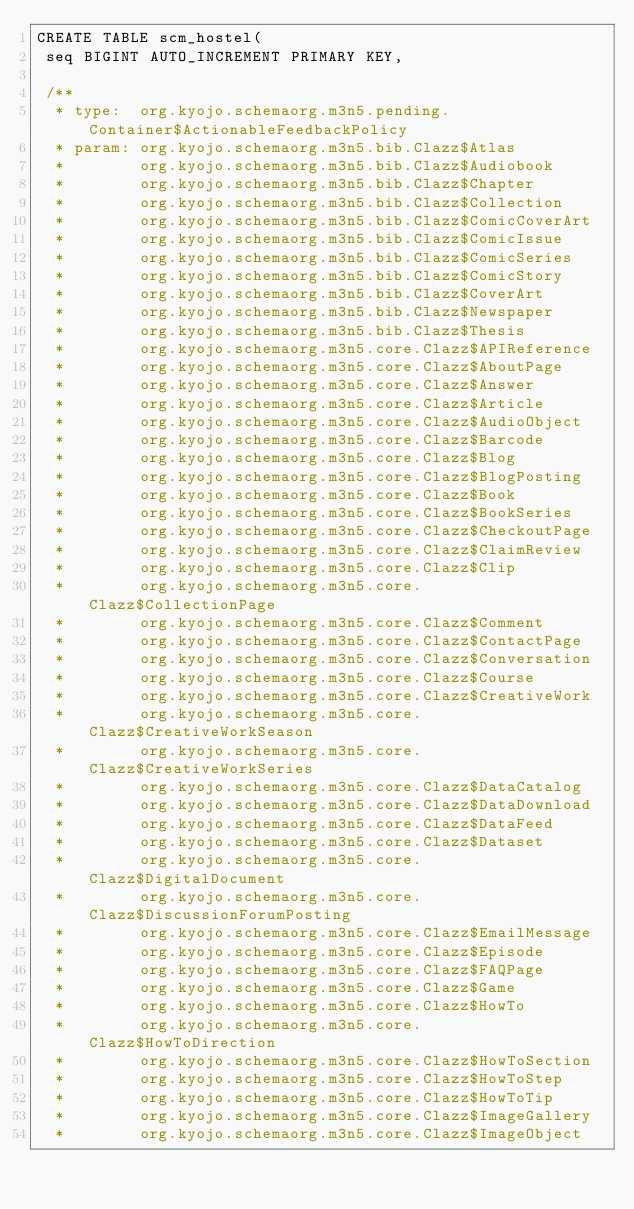<code> <loc_0><loc_0><loc_500><loc_500><_SQL_>CREATE TABLE scm_hostel(
 seq BIGINT AUTO_INCREMENT PRIMARY KEY,

 /**
  * type:  org.kyojo.schemaorg.m3n5.pending.Container$ActionableFeedbackPolicy
  * param: org.kyojo.schemaorg.m3n5.bib.Clazz$Atlas
  *        org.kyojo.schemaorg.m3n5.bib.Clazz$Audiobook
  *        org.kyojo.schemaorg.m3n5.bib.Clazz$Chapter
  *        org.kyojo.schemaorg.m3n5.bib.Clazz$Collection
  *        org.kyojo.schemaorg.m3n5.bib.Clazz$ComicCoverArt
  *        org.kyojo.schemaorg.m3n5.bib.Clazz$ComicIssue
  *        org.kyojo.schemaorg.m3n5.bib.Clazz$ComicSeries
  *        org.kyojo.schemaorg.m3n5.bib.Clazz$ComicStory
  *        org.kyojo.schemaorg.m3n5.bib.Clazz$CoverArt
  *        org.kyojo.schemaorg.m3n5.bib.Clazz$Newspaper
  *        org.kyojo.schemaorg.m3n5.bib.Clazz$Thesis
  *        org.kyojo.schemaorg.m3n5.core.Clazz$APIReference
  *        org.kyojo.schemaorg.m3n5.core.Clazz$AboutPage
  *        org.kyojo.schemaorg.m3n5.core.Clazz$Answer
  *        org.kyojo.schemaorg.m3n5.core.Clazz$Article
  *        org.kyojo.schemaorg.m3n5.core.Clazz$AudioObject
  *        org.kyojo.schemaorg.m3n5.core.Clazz$Barcode
  *        org.kyojo.schemaorg.m3n5.core.Clazz$Blog
  *        org.kyojo.schemaorg.m3n5.core.Clazz$BlogPosting
  *        org.kyojo.schemaorg.m3n5.core.Clazz$Book
  *        org.kyojo.schemaorg.m3n5.core.Clazz$BookSeries
  *        org.kyojo.schemaorg.m3n5.core.Clazz$CheckoutPage
  *        org.kyojo.schemaorg.m3n5.core.Clazz$ClaimReview
  *        org.kyojo.schemaorg.m3n5.core.Clazz$Clip
  *        org.kyojo.schemaorg.m3n5.core.Clazz$CollectionPage
  *        org.kyojo.schemaorg.m3n5.core.Clazz$Comment
  *        org.kyojo.schemaorg.m3n5.core.Clazz$ContactPage
  *        org.kyojo.schemaorg.m3n5.core.Clazz$Conversation
  *        org.kyojo.schemaorg.m3n5.core.Clazz$Course
  *        org.kyojo.schemaorg.m3n5.core.Clazz$CreativeWork
  *        org.kyojo.schemaorg.m3n5.core.Clazz$CreativeWorkSeason
  *        org.kyojo.schemaorg.m3n5.core.Clazz$CreativeWorkSeries
  *        org.kyojo.schemaorg.m3n5.core.Clazz$DataCatalog
  *        org.kyojo.schemaorg.m3n5.core.Clazz$DataDownload
  *        org.kyojo.schemaorg.m3n5.core.Clazz$DataFeed
  *        org.kyojo.schemaorg.m3n5.core.Clazz$Dataset
  *        org.kyojo.schemaorg.m3n5.core.Clazz$DigitalDocument
  *        org.kyojo.schemaorg.m3n5.core.Clazz$DiscussionForumPosting
  *        org.kyojo.schemaorg.m3n5.core.Clazz$EmailMessage
  *        org.kyojo.schemaorg.m3n5.core.Clazz$Episode
  *        org.kyojo.schemaorg.m3n5.core.Clazz$FAQPage
  *        org.kyojo.schemaorg.m3n5.core.Clazz$Game
  *        org.kyojo.schemaorg.m3n5.core.Clazz$HowTo
  *        org.kyojo.schemaorg.m3n5.core.Clazz$HowToDirection
  *        org.kyojo.schemaorg.m3n5.core.Clazz$HowToSection
  *        org.kyojo.schemaorg.m3n5.core.Clazz$HowToStep
  *        org.kyojo.schemaorg.m3n5.core.Clazz$HowToTip
  *        org.kyojo.schemaorg.m3n5.core.Clazz$ImageGallery
  *        org.kyojo.schemaorg.m3n5.core.Clazz$ImageObject</code> 